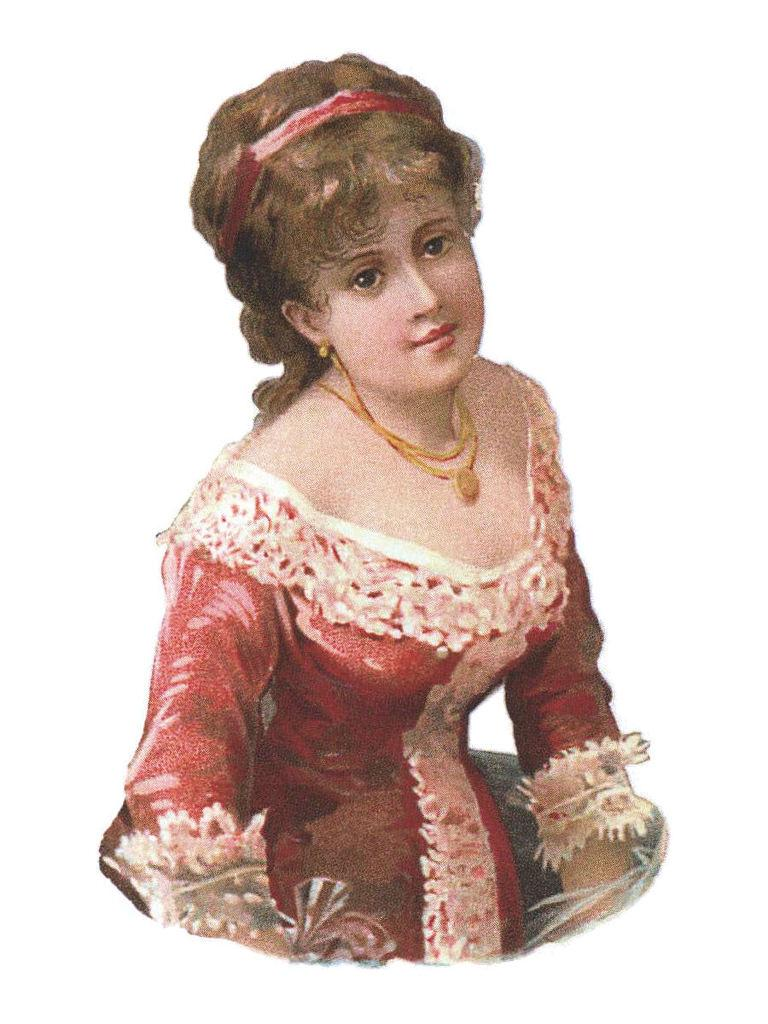What is the main subject of the image? There is a picture of a woman in the image. What month is the woman celebrating in the image? There is no indication of a specific month or celebration in the image; it only features a picture of a woman. 